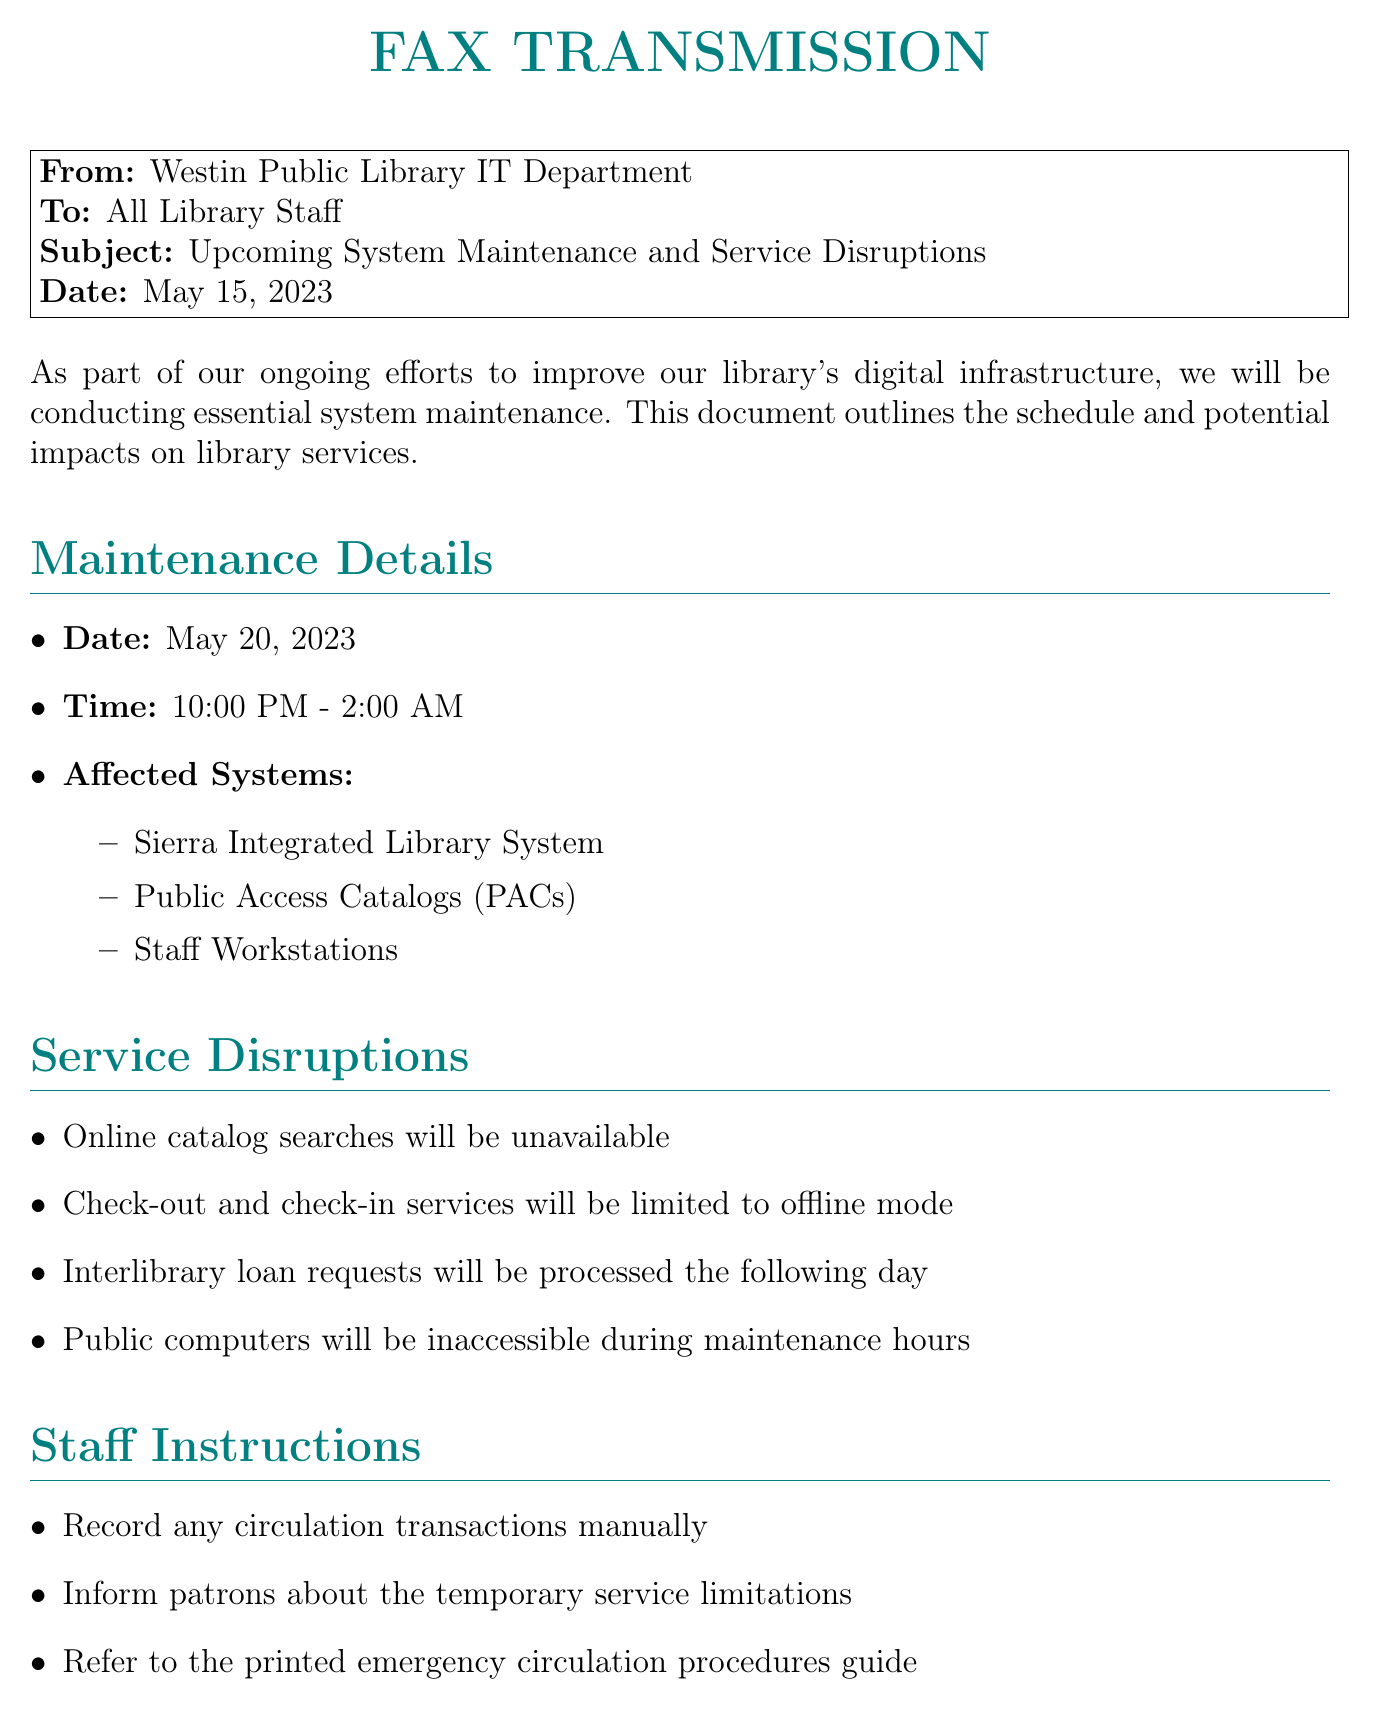What is the maintenance date? The maintenance date is explicitly stated in the document as May 20, 2023.
Answer: May 20, 2023 What time will the system maintenance occur? The maintenance time is listed in the document as running from 10:00 PM to 2:00 AM.
Answer: 10:00 PM - 2:00 AM Which system will be affected? The document lists several affected systems, including the Sierra Integrated Library System.
Answer: Sierra Integrated Library System What service will be unavailable during maintenance? The document specifies that online catalog searches will be unavailable during the maintenance period.
Answer: Online catalog searches Who should staff contact for questions? The fax provides contact information for David Chen, the IT Systems Administrator.
Answer: David Chen What should staff do for circulation transactions? The document advises staff to record any circulation transactions manually during the maintenance.
Answer: Record manually What are the benefits of this maintenance? The document states that the maintenance will improve system performance, among other benefits.
Answer: Improved system performance Why will interlibrary loan requests be delayed? The document indicates that interlibrary loan requests will be processed the following day due to the maintenance.
Answer: Processed the following day What color is used for the fax title? The document specifies that the title is in a color identified as library teal.
Answer: Library teal 